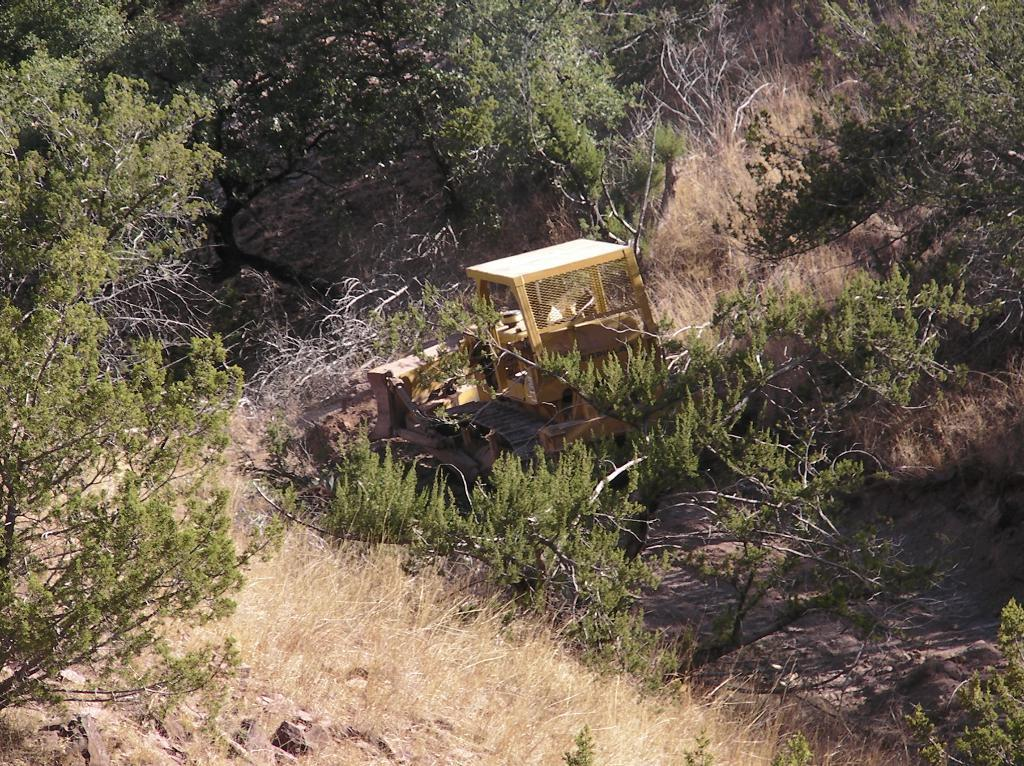What is the main subject of the image? The main subject of the image is a procaine. What type of surface is visible at the bottom of the image? There is grass on the surface at the bottom of the image. What can be seen in the background of the image? There are trees in the background of the image. How many sheep are visible in the image? There are no sheep present in the image. What type of plants are growing in the bathtub in the image? There is no bathtub or plants growing in a bathtub present in the image. 